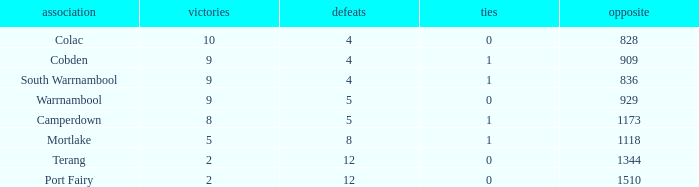What is the sum of losses for Against values over 1510? None. 